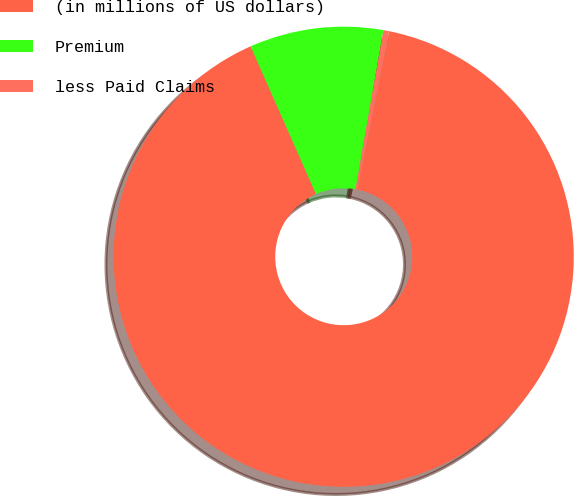<chart> <loc_0><loc_0><loc_500><loc_500><pie_chart><fcel>(in millions of US dollars)<fcel>Premium<fcel>less Paid Claims<nl><fcel>90.21%<fcel>9.39%<fcel>0.4%<nl></chart> 